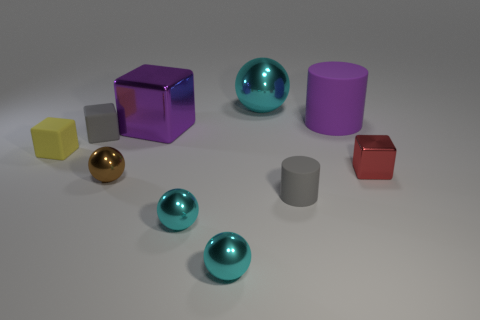There is a large thing that is the same color as the big rubber cylinder; what is its material?
Provide a short and direct response. Metal. How many small cyan things have the same shape as the brown metallic object?
Give a very brief answer. 2. There is a cylinder that is the same size as the purple metallic thing; what is it made of?
Offer a very short reply. Rubber. There is a cyan sphere behind the gray object on the right side of the metallic thing behind the large rubber thing; how big is it?
Your answer should be compact. Large. There is a cylinder to the right of the tiny cylinder; does it have the same color as the metallic cube on the left side of the gray matte cylinder?
Your answer should be compact. Yes. What number of cyan things are large balls or big shiny cubes?
Offer a very short reply. 1. How many blue metallic things have the same size as the purple metal object?
Provide a short and direct response. 0. Do the big cyan sphere that is on the right side of the big purple cube and the big purple cylinder have the same material?
Give a very brief answer. No. There is a object left of the gray rubber block; is there a shiny thing behind it?
Ensure brevity in your answer.  Yes. There is a tiny brown object that is the same shape as the large cyan metal thing; what is its material?
Offer a terse response. Metal. 